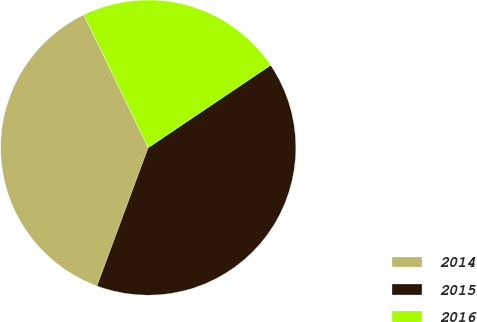Convert chart. <chart><loc_0><loc_0><loc_500><loc_500><pie_chart><fcel>2014<fcel>2015<fcel>2016<nl><fcel>37.16%<fcel>40.08%<fcel>22.76%<nl></chart> 